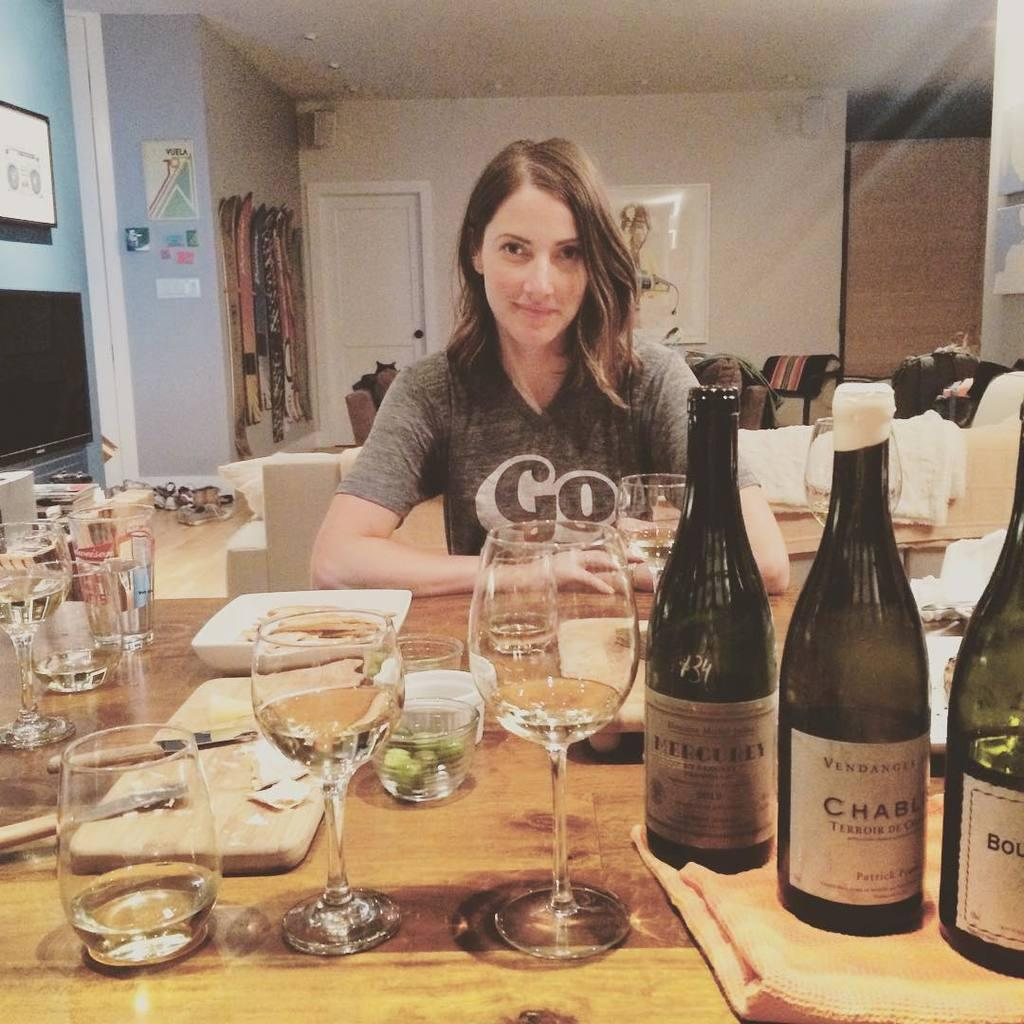<image>
Create a compact narrative representing the image presented. A woman with a shirt that says "Go" on the other side of the table from 3 wine bottles, one Mercurey, one Vendanger. 